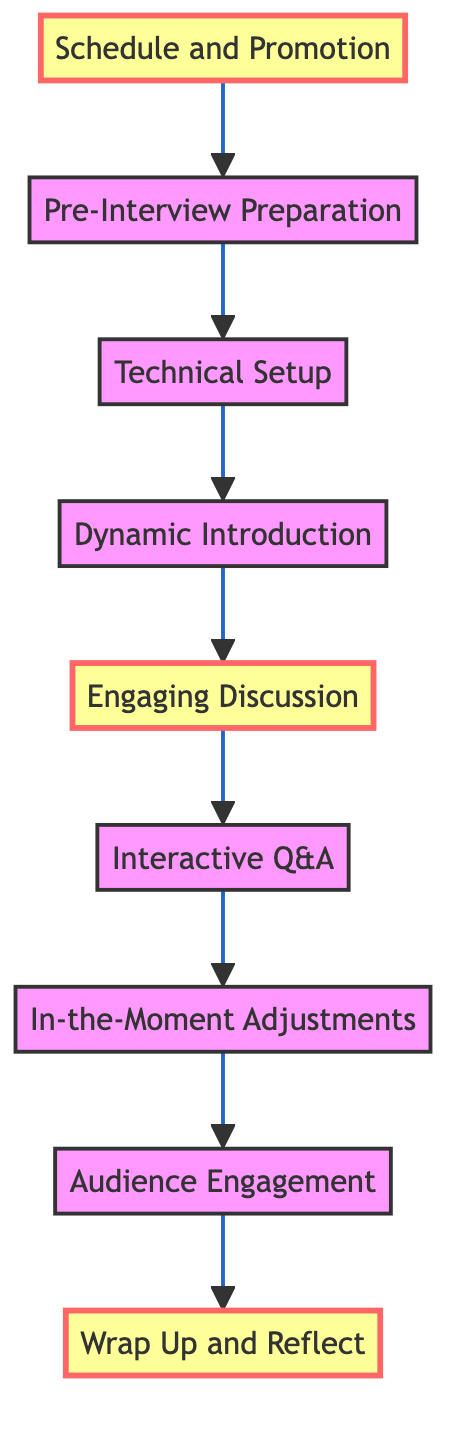What is the first step in the interview process? The flow chart indicates that the first step at the very bottom is "Schedule and Promotion." This is the starting point of the process, leading to the next steps.
Answer: Schedule and Promotion How many steps are involved in conducting the interview? By counting from "Schedule and Promotion" up to "Wrap Up and Reflect," I find there are a total of nine steps listed in the diagram.
Answer: 9 What step comes directly after "Engaging Discussion"? The diagram shows that "Interactive Q&A" follows immediately after "Engaging Discussion," meaning they are directly linked in the flow of the interview process.
Answer: Interactive Q&A Which step focuses on technical aspects? The step labeled “Technical Setup” emphasizes ensuring all technical equipment is functional, making it the specific step focused on technical aspects.
Answer: Technical Setup What are the two highlighted steps in the diagram? The steps highlighted in the diagram are "Wrap Up and Reflect" and "Engaging Discussion," indicating their importance in the overall process.
Answer: Wrap Up and Reflect, Engaging Discussion What step involves making real-time adjustments? The step "In-the-Moment Adjustments" is specifically mentioned for making real-time adjustments during the interview, demonstrating flexibility in the ongoing conversation.
Answer: In-the-Moment Adjustments Which instruction is last in the flow chart? In the diagram, the very last step at the top is "Wrap Up and Reflect," which concludes the entire process of conducting the interview.
Answer: Wrap Up and Reflect What is the relationship between "Dynamic Introduction" and "Engaging Discussion"? The relationship is that "Dynamic Introduction" precedes "Engaging Discussion," showing the flow direction from introducing the guest to starting the discussion about improv.
Answer: "Dynamic Introduction" precedes "Engaging Discussion" What step requires preparation with the guest? The step "Pre-Interview Preparation" is dedicated to researching and preparing for the interview, which includes discussing the structure and flow with the guest.
Answer: Pre-Interview Preparation 